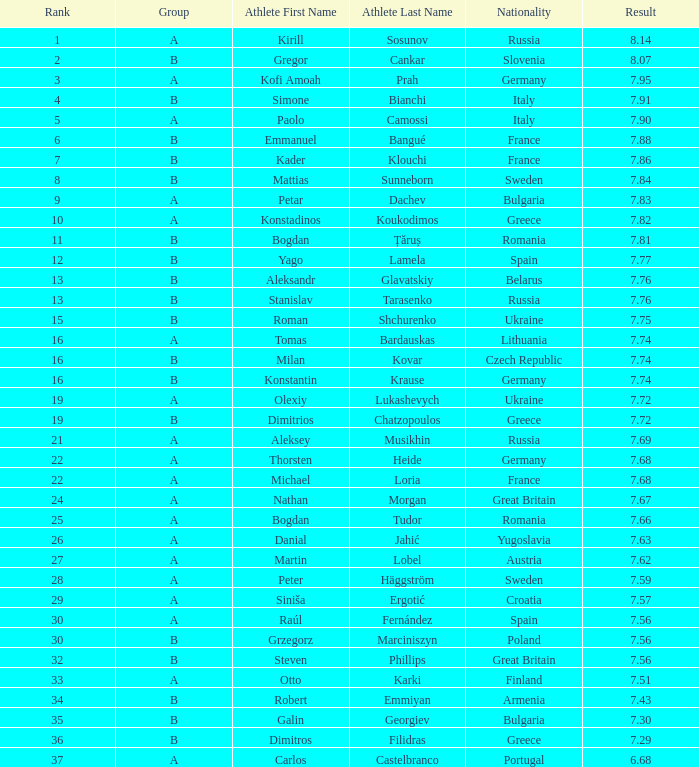Which athlete's rank is more than 15 when the result is less than 7.68, the group is b, and the nationality listed is Great Britain? Steven Phillips. 